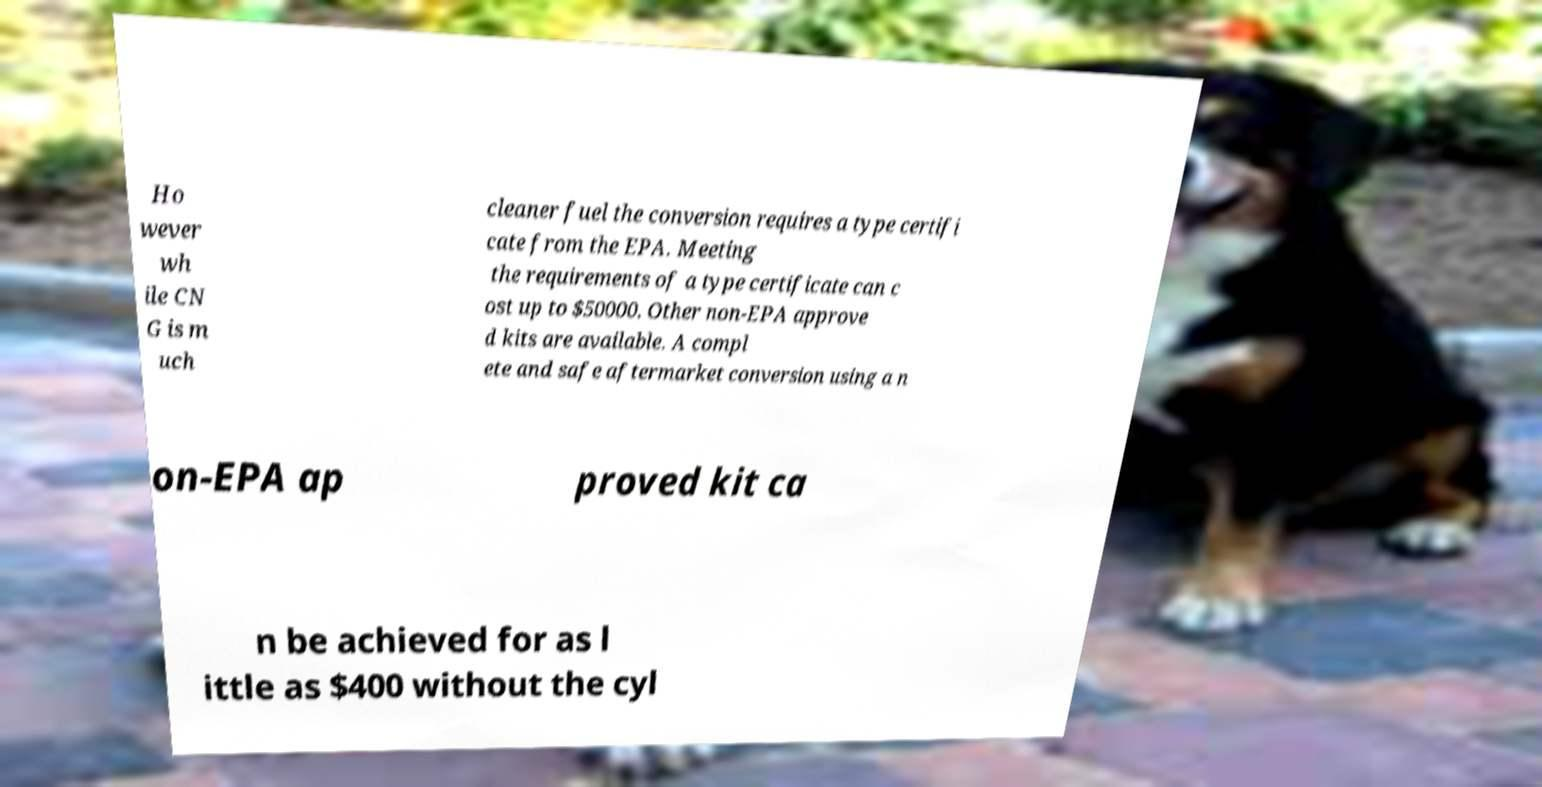Please read and relay the text visible in this image. What does it say? Ho wever wh ile CN G is m uch cleaner fuel the conversion requires a type certifi cate from the EPA. Meeting the requirements of a type certificate can c ost up to $50000. Other non-EPA approve d kits are available. A compl ete and safe aftermarket conversion using a n on-EPA ap proved kit ca n be achieved for as l ittle as $400 without the cyl 